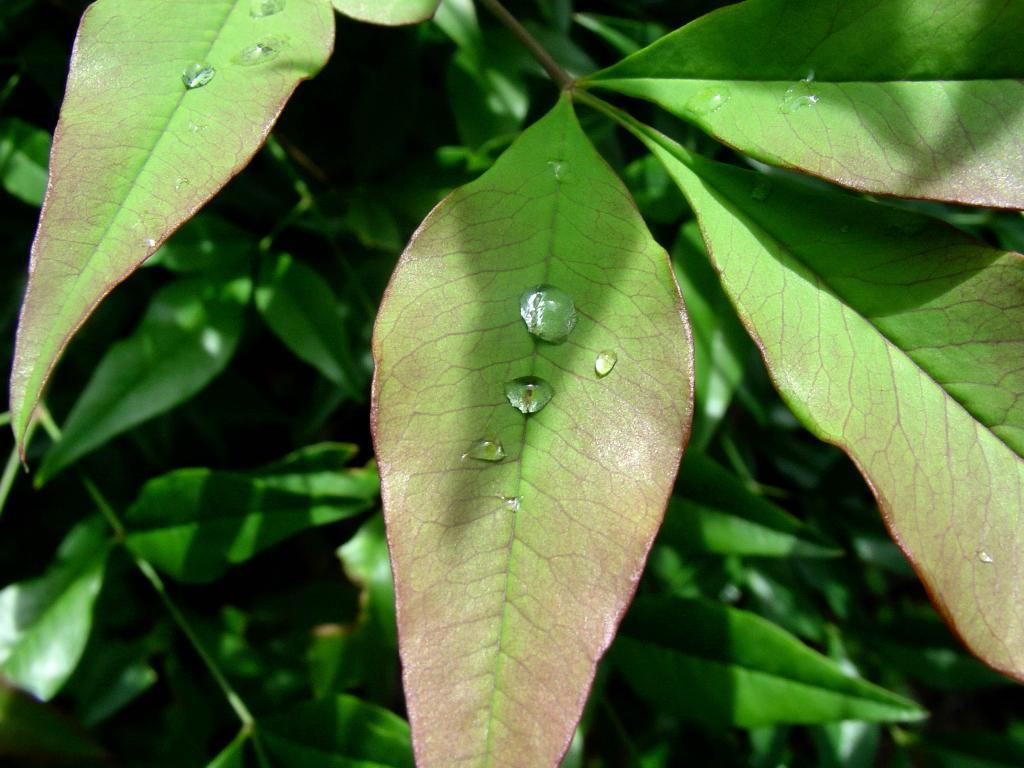Describe this image in one or two sentences. In this image there are leaves. 